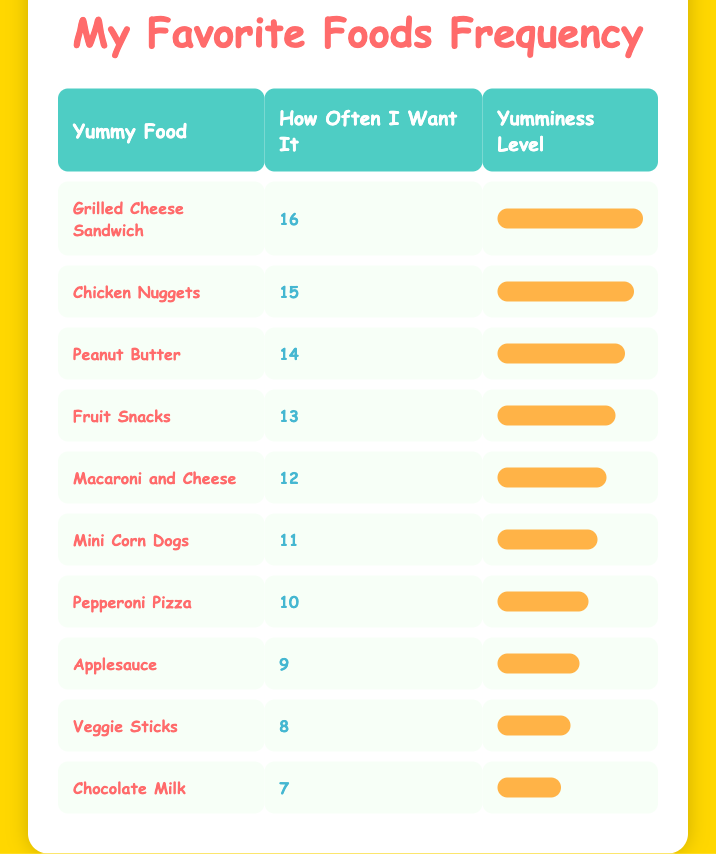What is the most frequently requested kid-friendly ingredient? The table shows that the ingredient with the highest frequency is the Grilled Cheese Sandwich, which is requested 16 times.
Answer: Grilled Cheese Sandwich How many times do kids want to eat Macaroni and Cheese? According to the table, Macaroni and Cheese is wanted 12 times by kids.
Answer: 12 Is the frequency of Veggie Sticks greater than that of Chocolate Milk? Veggie Sticks have a frequency of 8, while Chocolate Milk has a frequency of 7. Since 8 is greater than 7, the statement is true.
Answer: Yes What is the total frequency of the top three ingredients? The top three ingredients are Grilled Cheese Sandwich (16), Chicken Nuggets (15), and Peanut Butter (14). Adding these frequencies gives 16 + 15 + 14 = 45.
Answer: 45 What are the two least requested ingredients? The table shows that the two least requested ingredients are Chocolate Milk (7) and Veggie Sticks (8).
Answer: Chocolate Milk and Veggie Sticks If a kid wanted to eat one of each of the top five ingredients, how many total meals would that be? The top five ingredients are Grilled Cheese Sandwich (16), Chicken Nuggets (15), Peanut Butter (14), Fruit Snacks (13), and Macaroni and Cheese (12). To find the total, we take 1 from each which equals 5 meals regardless of their frequencies.
Answer: 5 What is the average frequency of all the ingredients listed? To find the average, first, we sum all the frequencies: 16 + 15 + 14 + 13 + 12 + 11 + 10 + 9 + 8 + 7 = 115. There are 10 ingredients, so we divide 115 by 10, giving an average of 11.5.
Answer: 11.5 Are there more ingredients requested 10 times or less than there are more than 10 times? Looking at the table, there are four ingredients requested 10 times or fewer (Chocolate Milk, Veggie Sticks, Applesauce, and Pepperoni Pizza). There are six ingredients requested more than 10 times. Thus, there are more ingredients requested more than 10 times.
Answer: Yes Which ingredient has a frequency that’s exactly one less than Mini Corn Dogs? Mini Corn Dogs have a frequency of 11. The ingredient with a frequency of 10 is Pepperoni Pizza, which is one less.
Answer: Pepperoni Pizza 